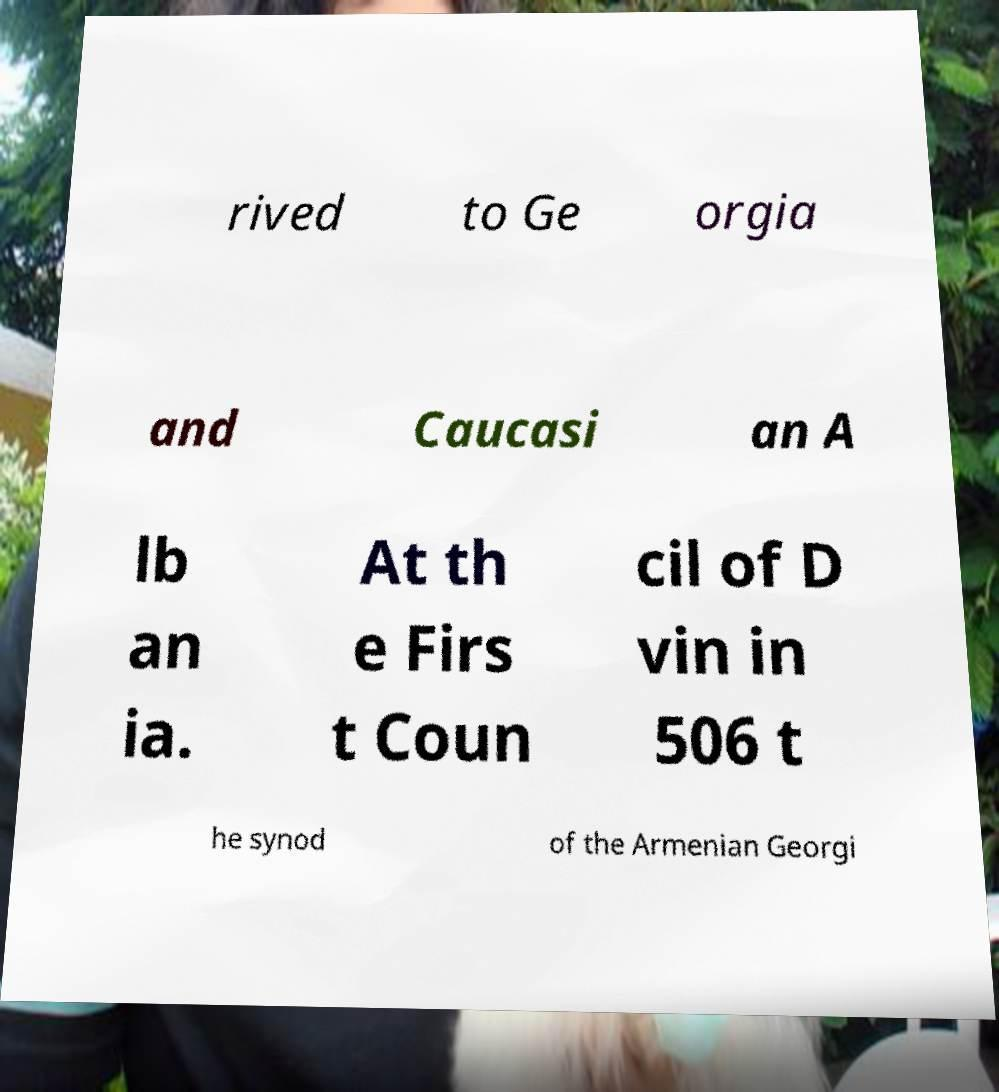Could you extract and type out the text from this image? rived to Ge orgia and Caucasi an A lb an ia. At th e Firs t Coun cil of D vin in 506 t he synod of the Armenian Georgi 